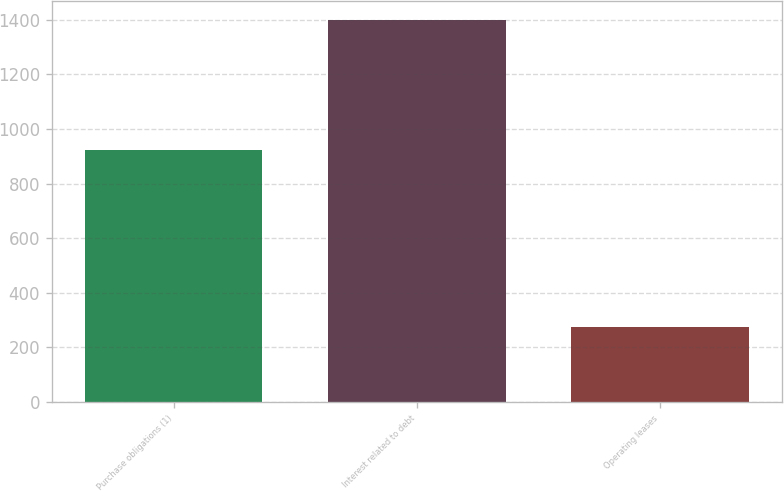Convert chart. <chart><loc_0><loc_0><loc_500><loc_500><bar_chart><fcel>Purchase obligations (1)<fcel>Interest related to debt<fcel>Operating leases<nl><fcel>922<fcel>1399<fcel>276<nl></chart> 